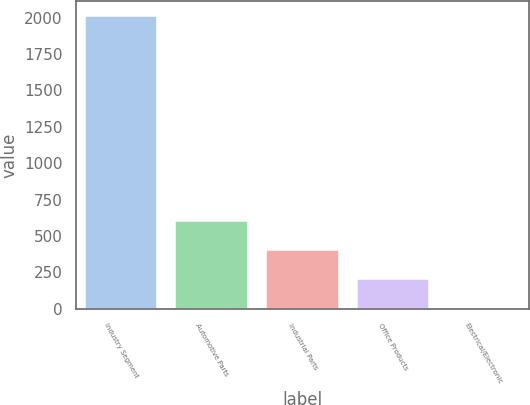<chart> <loc_0><loc_0><loc_500><loc_500><bar_chart><fcel>Industry Segment<fcel>Automotive Parts<fcel>Industrial Parts<fcel>Office Products<fcel>Electrical/Electronic<nl><fcel>2012<fcel>606.4<fcel>405.6<fcel>204.8<fcel>4<nl></chart> 